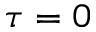Convert formula to latex. <formula><loc_0><loc_0><loc_500><loc_500>\tau = 0</formula> 